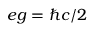Convert formula to latex. <formula><loc_0><loc_0><loc_500><loc_500>e g = \hbar { c } / 2</formula> 